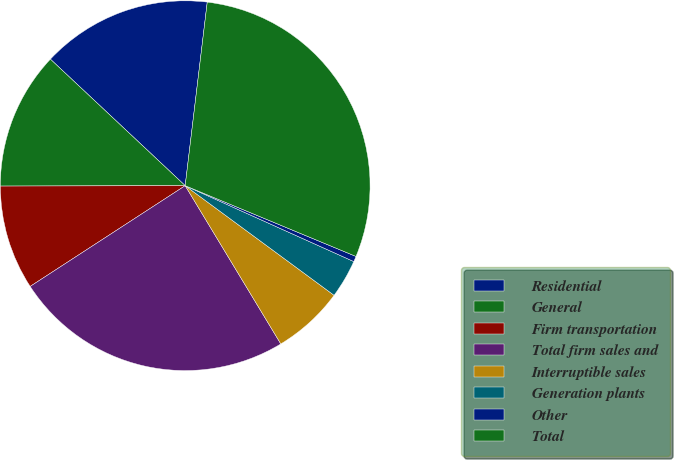Convert chart to OTSL. <chart><loc_0><loc_0><loc_500><loc_500><pie_chart><fcel>Residential<fcel>General<fcel>Firm transportation<fcel>Total firm sales and<fcel>Interruptible sales<fcel>Generation plants<fcel>Other<fcel>Total<nl><fcel>14.91%<fcel>12.03%<fcel>9.14%<fcel>24.48%<fcel>6.25%<fcel>3.37%<fcel>0.48%<fcel>29.35%<nl></chart> 